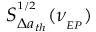Convert formula to latex. <formula><loc_0><loc_0><loc_500><loc_500>S _ { \Delta a _ { t h } } ^ { ^ { 1 / 2 } } ( \nu _ { _ { E P } } )</formula> 